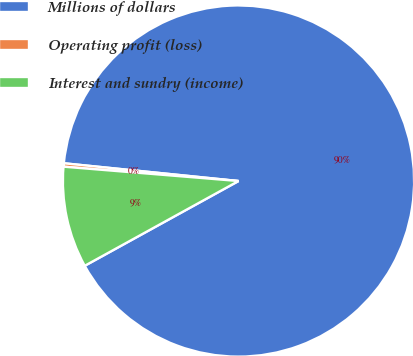<chart> <loc_0><loc_0><loc_500><loc_500><pie_chart><fcel>Millions of dollars<fcel>Operating profit (loss)<fcel>Interest and sundry (income)<nl><fcel>90.37%<fcel>0.31%<fcel>9.32%<nl></chart> 